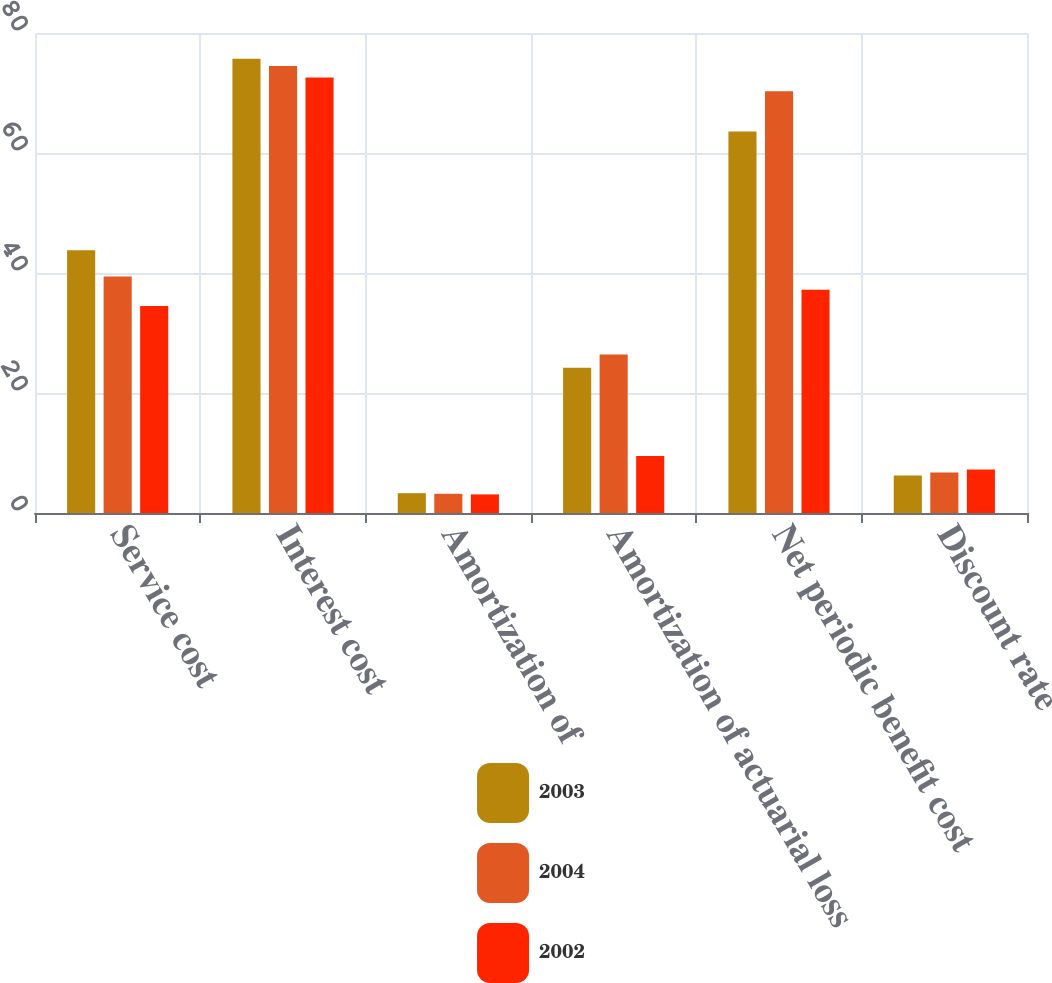Convert chart. <chart><loc_0><loc_0><loc_500><loc_500><stacked_bar_chart><ecel><fcel>Service cost<fcel>Interest cost<fcel>Amortization of<fcel>Amortization of actuarial loss<fcel>Net periodic benefit cost<fcel>Discount rate<nl><fcel>2003<fcel>43.8<fcel>75.7<fcel>3.3<fcel>24.2<fcel>63.6<fcel>6.25<nl><fcel>2004<fcel>39.4<fcel>74.5<fcel>3.2<fcel>26.4<fcel>70.3<fcel>6.75<nl><fcel>2002<fcel>34.5<fcel>72.6<fcel>3.1<fcel>9.5<fcel>37.2<fcel>7.25<nl></chart> 